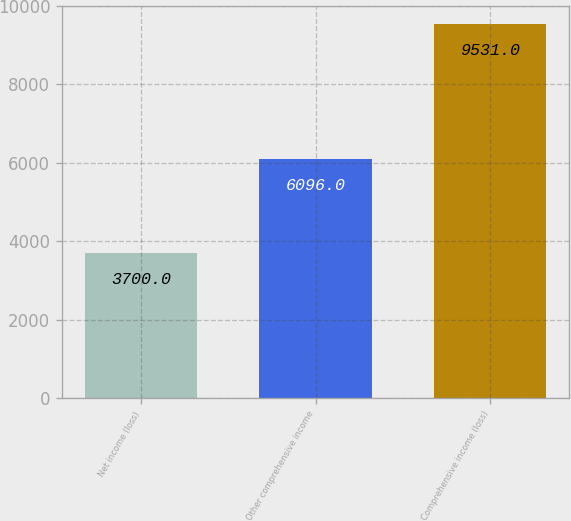Convert chart to OTSL. <chart><loc_0><loc_0><loc_500><loc_500><bar_chart><fcel>Net income (loss)<fcel>Other comprehensive income<fcel>Comprehensive income (loss)<nl><fcel>3700<fcel>6096<fcel>9531<nl></chart> 